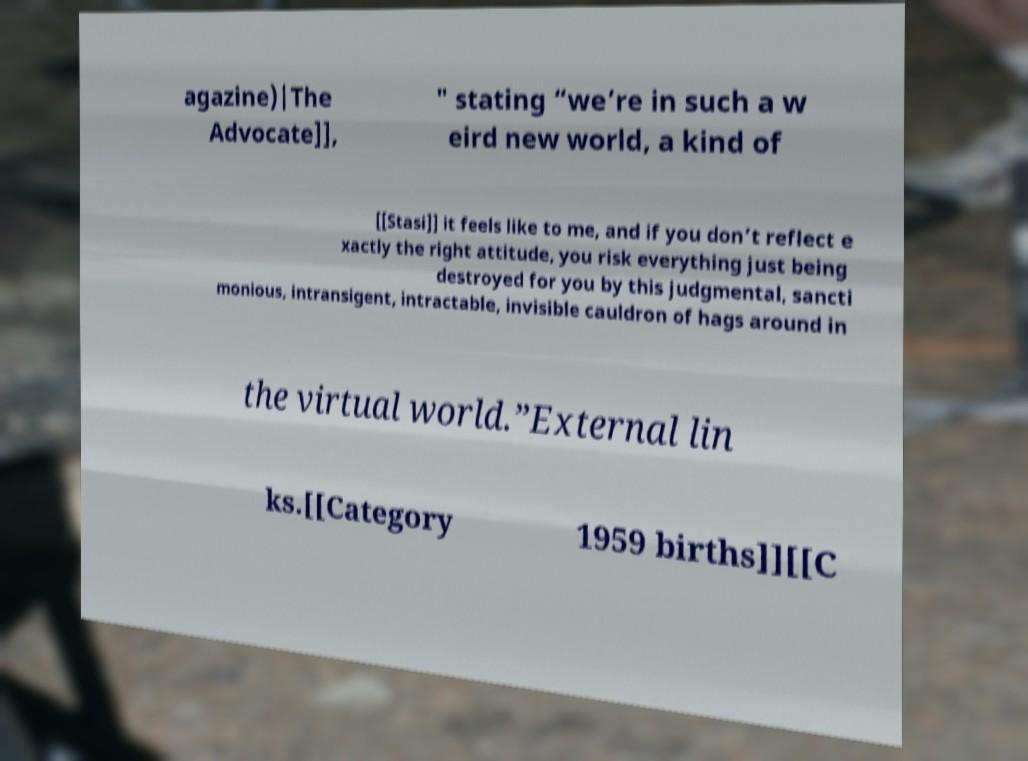There's text embedded in this image that I need extracted. Can you transcribe it verbatim? agazine)|The Advocate]], " stating “we’re in such a w eird new world, a kind of [[Stasi]] it feels like to me, and if you don’t reflect e xactly the right attitude, you risk everything just being destroyed for you by this judgmental, sancti monious, intransigent, intractable, invisible cauldron of hags around in the virtual world.”External lin ks.[[Category 1959 births]][[C 